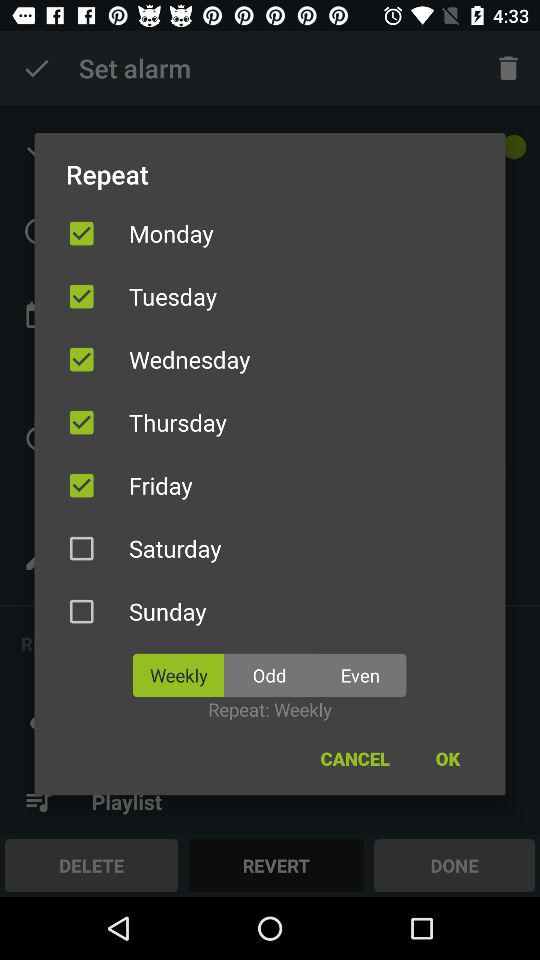What are the options for the repetition of the alarm? The options for the repetition of the alarm are "Weekly", "Odd" and "Even". 